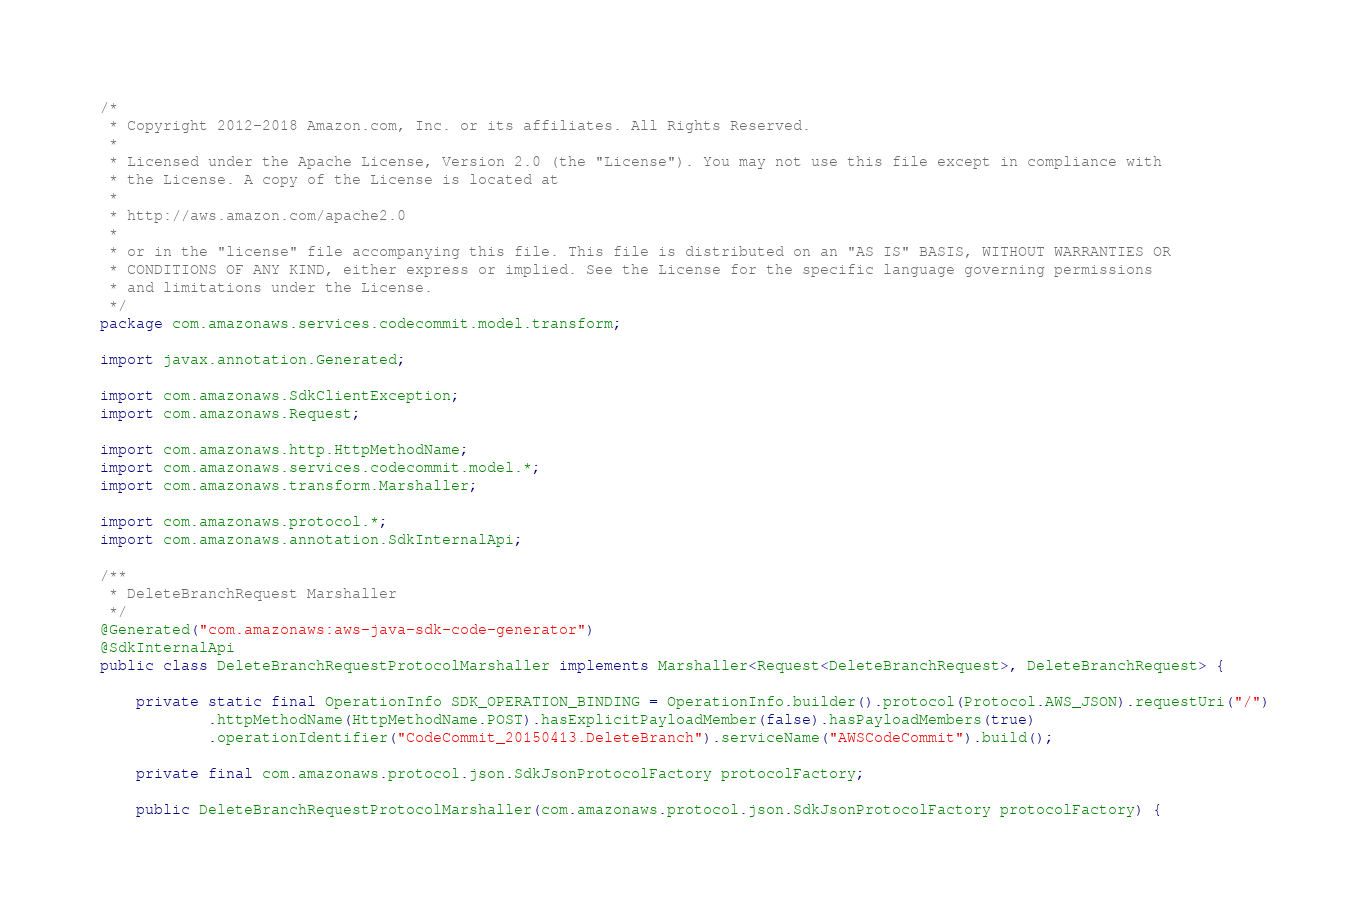<code> <loc_0><loc_0><loc_500><loc_500><_Java_>/*
 * Copyright 2012-2018 Amazon.com, Inc. or its affiliates. All Rights Reserved.
 * 
 * Licensed under the Apache License, Version 2.0 (the "License"). You may not use this file except in compliance with
 * the License. A copy of the License is located at
 * 
 * http://aws.amazon.com/apache2.0
 * 
 * or in the "license" file accompanying this file. This file is distributed on an "AS IS" BASIS, WITHOUT WARRANTIES OR
 * CONDITIONS OF ANY KIND, either express or implied. See the License for the specific language governing permissions
 * and limitations under the License.
 */
package com.amazonaws.services.codecommit.model.transform;

import javax.annotation.Generated;

import com.amazonaws.SdkClientException;
import com.amazonaws.Request;

import com.amazonaws.http.HttpMethodName;
import com.amazonaws.services.codecommit.model.*;
import com.amazonaws.transform.Marshaller;

import com.amazonaws.protocol.*;
import com.amazonaws.annotation.SdkInternalApi;

/**
 * DeleteBranchRequest Marshaller
 */
@Generated("com.amazonaws:aws-java-sdk-code-generator")
@SdkInternalApi
public class DeleteBranchRequestProtocolMarshaller implements Marshaller<Request<DeleteBranchRequest>, DeleteBranchRequest> {

    private static final OperationInfo SDK_OPERATION_BINDING = OperationInfo.builder().protocol(Protocol.AWS_JSON).requestUri("/")
            .httpMethodName(HttpMethodName.POST).hasExplicitPayloadMember(false).hasPayloadMembers(true)
            .operationIdentifier("CodeCommit_20150413.DeleteBranch").serviceName("AWSCodeCommit").build();

    private final com.amazonaws.protocol.json.SdkJsonProtocolFactory protocolFactory;

    public DeleteBranchRequestProtocolMarshaller(com.amazonaws.protocol.json.SdkJsonProtocolFactory protocolFactory) {</code> 